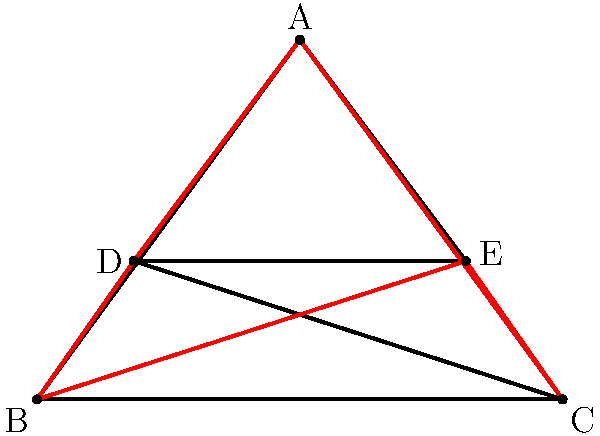Rock on, glam enthusiasts! Imagine you're designing a mind-blowing pentagram-shaped spotlight formation for your next epic concert. The pentagram is formed by connecting the vertices of a regular pentagon with its diagonals, creating a star-like shape. If the internal angle of the regular pentagon is $108^\circ$, what's the measure of one of the acute angles formed at the points of the star? Get ready to dazzle the crowd with your mathematical prowess! Let's break this down step by step, just like building up to an awesome guitar solo:

1) First, recall that the sum of the angles in a pentagon is $(5-2) \times 180^\circ = 540^\circ$.

2) In a regular pentagon, all angles are equal. So, each angle of the pentagon is $540^\circ \div 5 = 108^\circ$.

3) Now, let's focus on one of the triangles formed at the point of the star. It's an isosceles triangle because two of its sides are diagonals of the pentagon.

4) The base angles of this isosceles triangle are equal. Let's call the measure of each of these angles $x$.

5) The angle at the vertex of this triangle (at the point of the star) is $36^\circ$. Why? Because $360^\circ \div 5 = 72^\circ$, and $72^\circ \div 2 = 36^\circ$.

6) Now, we can set up an equation based on the fact that the sum of angles in a triangle is $180^\circ$:

   $x + x + 36^\circ = 180^\circ$

7) Simplifying:
   $2x + 36^\circ = 180^\circ$
   $2x = 144^\circ$
   $x = 72^\circ$

8) Therefore, the acute angle at each point of the star is $72^\circ$.

Rock on with your mathematical spotlight design!
Answer: $72^\circ$ 